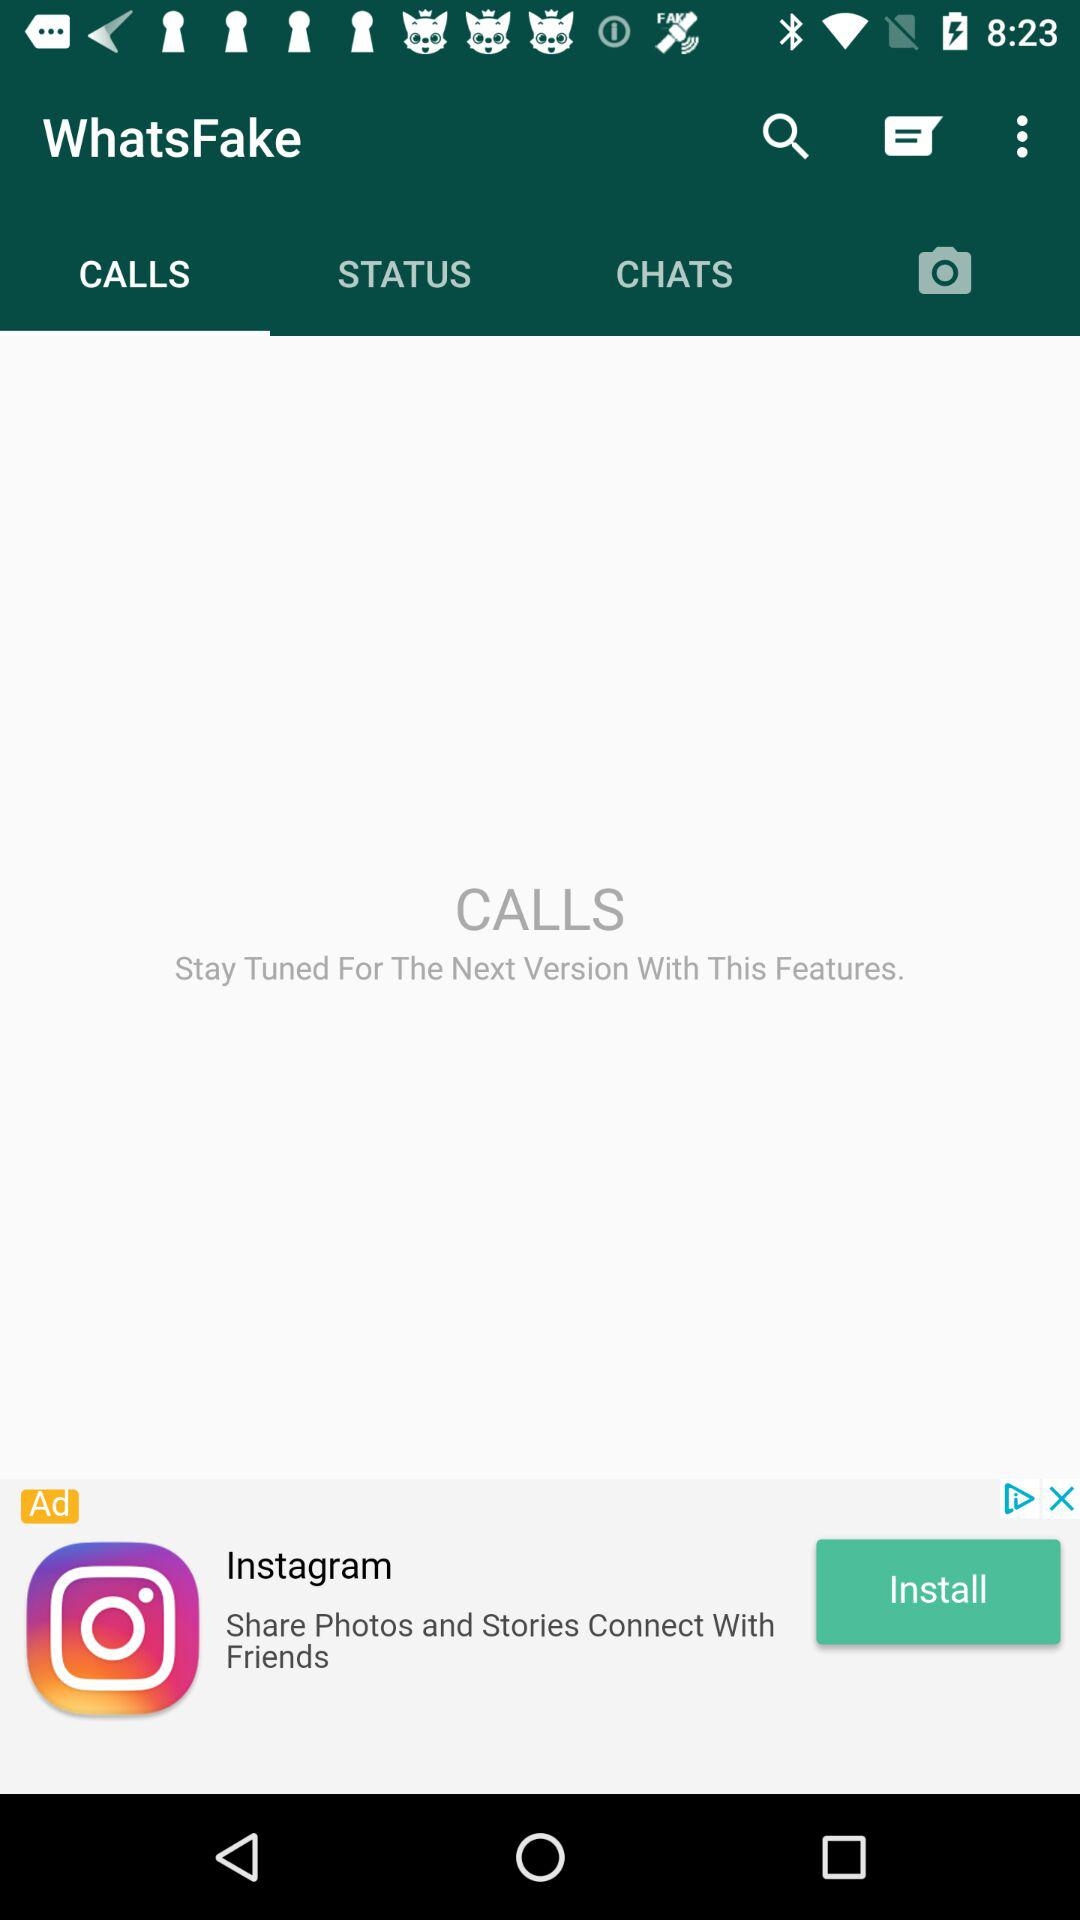What is the selected tab? The selected tab is "CALLS". 